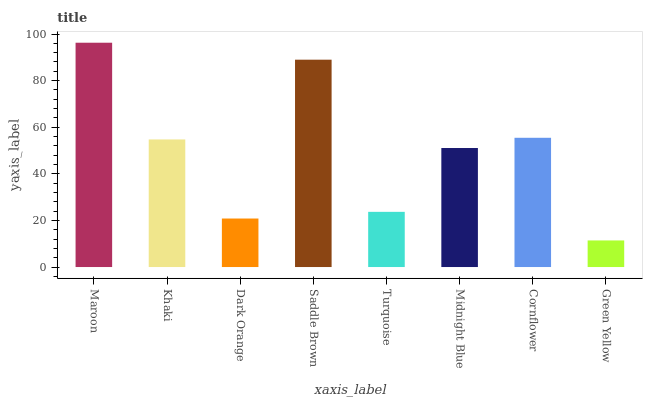Is Khaki the minimum?
Answer yes or no. No. Is Khaki the maximum?
Answer yes or no. No. Is Maroon greater than Khaki?
Answer yes or no. Yes. Is Khaki less than Maroon?
Answer yes or no. Yes. Is Khaki greater than Maroon?
Answer yes or no. No. Is Maroon less than Khaki?
Answer yes or no. No. Is Khaki the high median?
Answer yes or no. Yes. Is Midnight Blue the low median?
Answer yes or no. Yes. Is Midnight Blue the high median?
Answer yes or no. No. Is Khaki the low median?
Answer yes or no. No. 